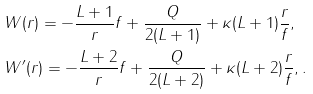Convert formula to latex. <formula><loc_0><loc_0><loc_500><loc_500>& W ( r ) = - \frac { L + 1 } { r } f + \frac { Q } { 2 ( L + 1 ) } + \kappa ( L + 1 ) \frac { r } { f } , \\ & W ^ { \prime } ( r ) = - \frac { L + 2 } { r } f + \frac { Q } { 2 ( L + 2 ) } + \kappa ( L + 2 ) \frac { r } { f } , .</formula> 